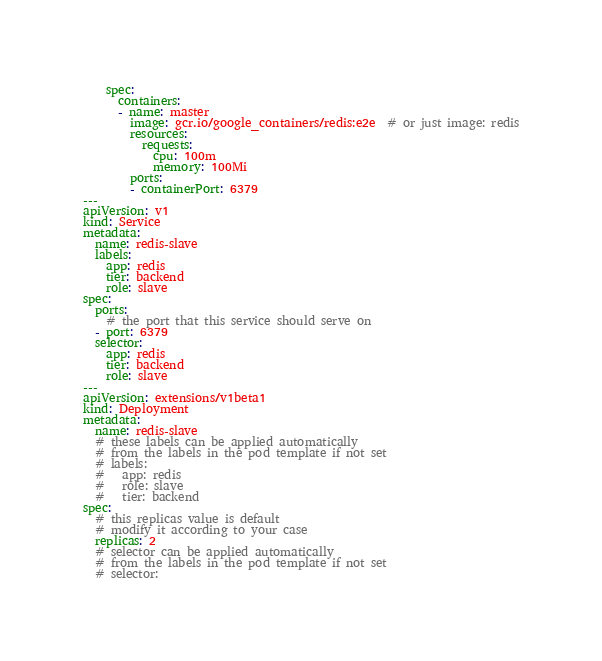<code> <loc_0><loc_0><loc_500><loc_500><_YAML_>    spec:
      containers:
      - name: master
        image: gcr.io/google_containers/redis:e2e  # or just image: redis
        resources:
          requests:
            cpu: 100m
            memory: 100Mi
        ports:
        - containerPort: 6379
---
apiVersion: v1
kind: Service
metadata:
  name: redis-slave
  labels:
    app: redis
    tier: backend
    role: slave
spec:
  ports:
    # the port that this service should serve on
  - port: 6379
  selector:
    app: redis
    tier: backend
    role: slave
---
apiVersion: extensions/v1beta1
kind: Deployment
metadata:
  name: redis-slave
  # these labels can be applied automatically
  # from the labels in the pod template if not set
  # labels:
  #   app: redis
  #   role: slave
  #   tier: backend
spec:
  # this replicas value is default
  # modify it according to your case
  replicas: 2
  # selector can be applied automatically
  # from the labels in the pod template if not set
  # selector:</code> 